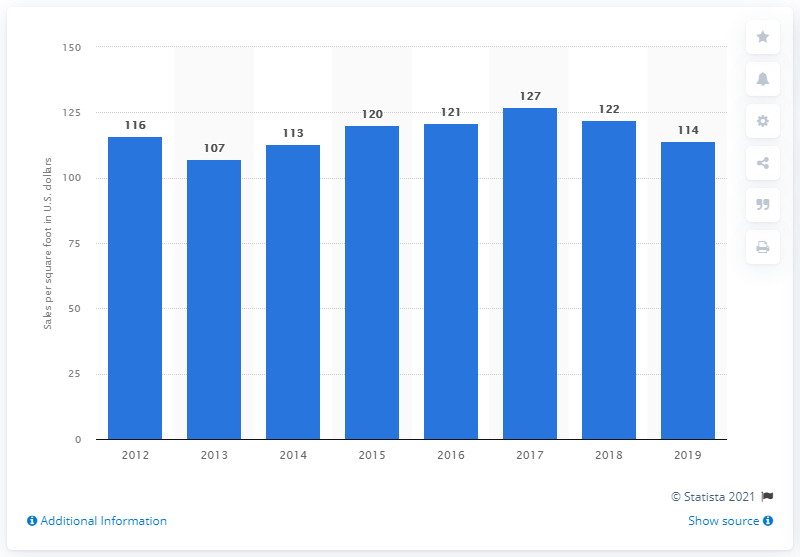Highlight a few significant elements in this photo. In 2019, J.C. Penney generated approximately $114 in sales per square foot of retail space. 